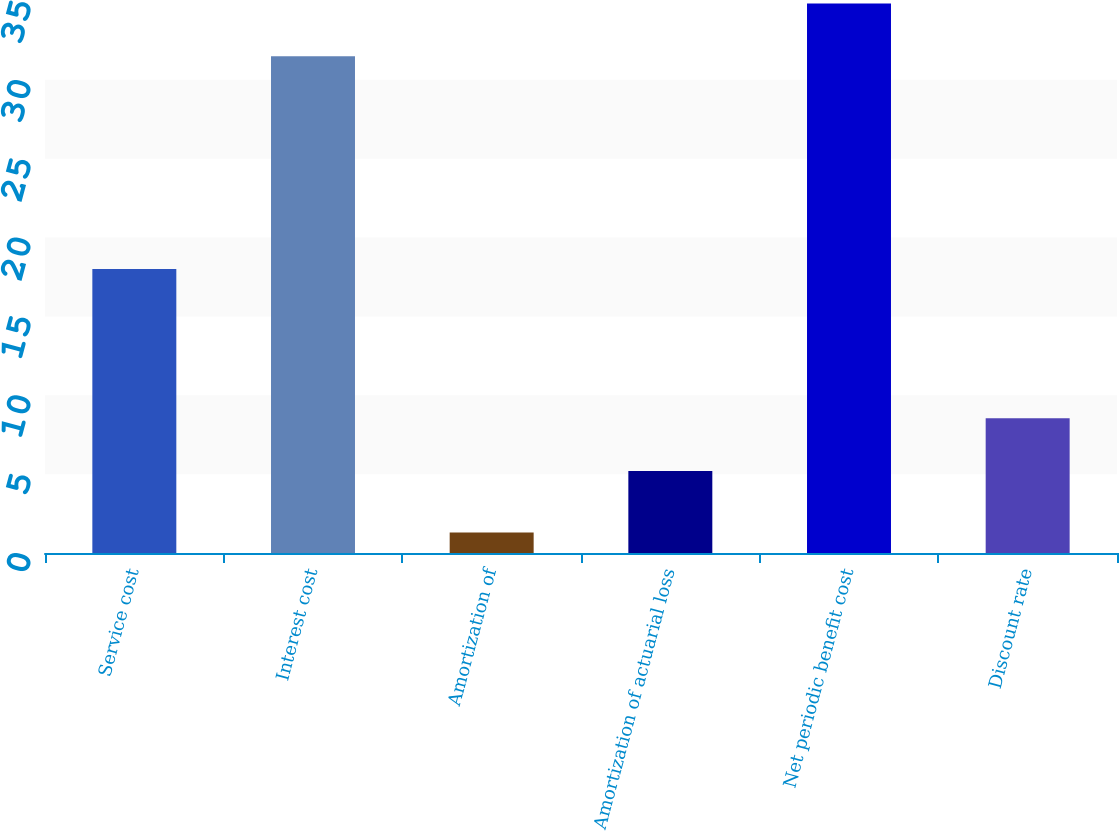Convert chart to OTSL. <chart><loc_0><loc_0><loc_500><loc_500><bar_chart><fcel>Service cost<fcel>Interest cost<fcel>Amortization of<fcel>Amortization of actuarial loss<fcel>Net periodic benefit cost<fcel>Discount rate<nl><fcel>18<fcel>31.5<fcel>1.3<fcel>5.2<fcel>34.84<fcel>8.54<nl></chart> 